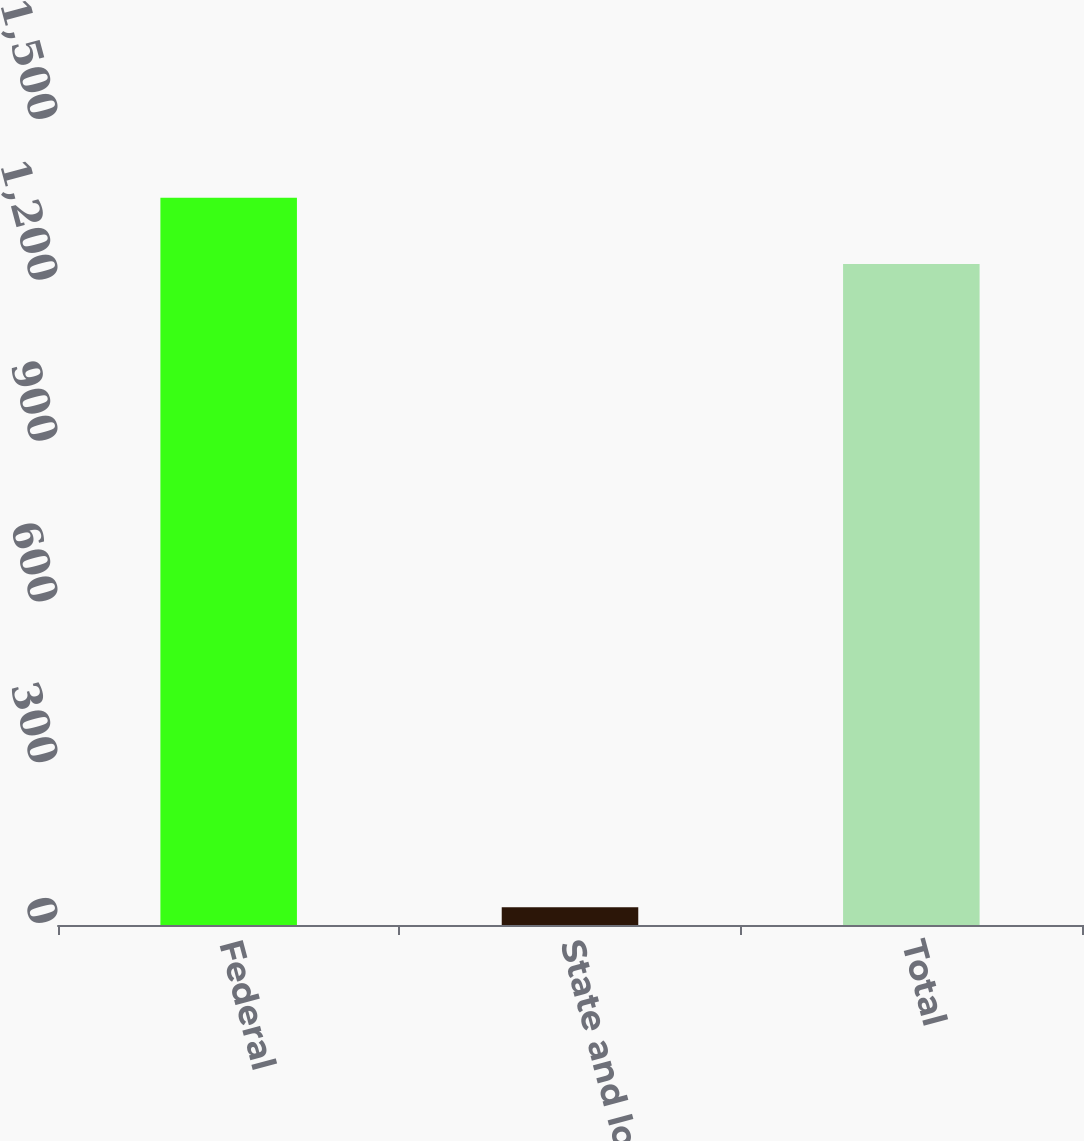Convert chart. <chart><loc_0><loc_0><loc_500><loc_500><bar_chart><fcel>Federal<fcel>State and local<fcel>Total<nl><fcel>1356.7<fcel>33<fcel>1233<nl></chart> 